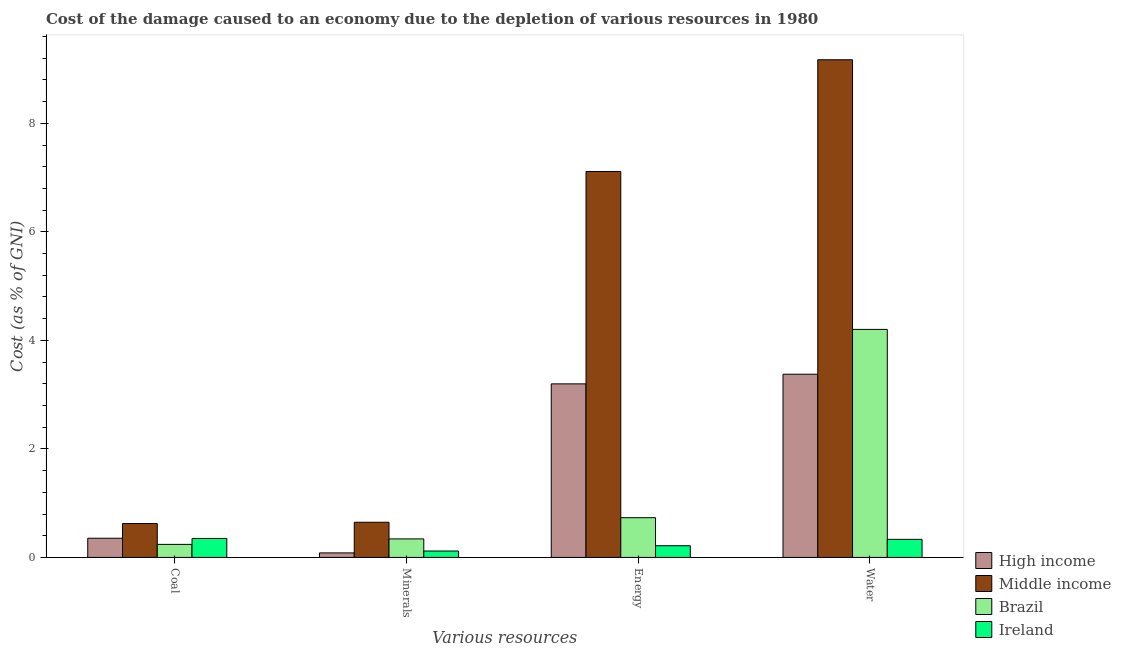How many different coloured bars are there?
Make the answer very short. 4. Are the number of bars per tick equal to the number of legend labels?
Keep it short and to the point. Yes. How many bars are there on the 4th tick from the left?
Your response must be concise. 4. How many bars are there on the 1st tick from the right?
Offer a very short reply. 4. What is the label of the 4th group of bars from the left?
Ensure brevity in your answer.  Water. What is the cost of damage due to depletion of coal in Middle income?
Your answer should be very brief. 0.62. Across all countries, what is the maximum cost of damage due to depletion of minerals?
Offer a very short reply. 0.65. Across all countries, what is the minimum cost of damage due to depletion of energy?
Give a very brief answer. 0.22. In which country was the cost of damage due to depletion of coal maximum?
Your response must be concise. Middle income. What is the total cost of damage due to depletion of water in the graph?
Keep it short and to the point. 17.08. What is the difference between the cost of damage due to depletion of water in Ireland and that in High income?
Keep it short and to the point. -3.04. What is the difference between the cost of damage due to depletion of minerals in Ireland and the cost of damage due to depletion of coal in High income?
Your answer should be very brief. -0.24. What is the average cost of damage due to depletion of minerals per country?
Offer a very short reply. 0.3. What is the difference between the cost of damage due to depletion of coal and cost of damage due to depletion of energy in Middle income?
Provide a succinct answer. -6.49. In how many countries, is the cost of damage due to depletion of water greater than 8.4 %?
Offer a terse response. 1. What is the ratio of the cost of damage due to depletion of coal in Brazil to that in High income?
Offer a very short reply. 0.68. What is the difference between the highest and the second highest cost of damage due to depletion of energy?
Offer a very short reply. 3.91. What is the difference between the highest and the lowest cost of damage due to depletion of minerals?
Give a very brief answer. 0.56. What does the 1st bar from the left in Minerals represents?
Offer a very short reply. High income. Is it the case that in every country, the sum of the cost of damage due to depletion of coal and cost of damage due to depletion of minerals is greater than the cost of damage due to depletion of energy?
Provide a short and direct response. No. How many countries are there in the graph?
Provide a short and direct response. 4. What is the difference between two consecutive major ticks on the Y-axis?
Provide a succinct answer. 2. Does the graph contain grids?
Ensure brevity in your answer.  No. How many legend labels are there?
Your response must be concise. 4. What is the title of the graph?
Offer a very short reply. Cost of the damage caused to an economy due to the depletion of various resources in 1980 . Does "Heavily indebted poor countries" appear as one of the legend labels in the graph?
Offer a very short reply. No. What is the label or title of the X-axis?
Offer a terse response. Various resources. What is the label or title of the Y-axis?
Your answer should be compact. Cost (as % of GNI). What is the Cost (as % of GNI) of High income in Coal?
Your response must be concise. 0.35. What is the Cost (as % of GNI) in Middle income in Coal?
Offer a very short reply. 0.62. What is the Cost (as % of GNI) in Brazil in Coal?
Your answer should be very brief. 0.24. What is the Cost (as % of GNI) of Ireland in Coal?
Provide a succinct answer. 0.35. What is the Cost (as % of GNI) of High income in Minerals?
Give a very brief answer. 0.08. What is the Cost (as % of GNI) of Middle income in Minerals?
Offer a terse response. 0.65. What is the Cost (as % of GNI) in Brazil in Minerals?
Make the answer very short. 0.34. What is the Cost (as % of GNI) in Ireland in Minerals?
Your response must be concise. 0.12. What is the Cost (as % of GNI) in High income in Energy?
Your response must be concise. 3.2. What is the Cost (as % of GNI) of Middle income in Energy?
Provide a short and direct response. 7.11. What is the Cost (as % of GNI) in Brazil in Energy?
Make the answer very short. 0.73. What is the Cost (as % of GNI) of Ireland in Energy?
Provide a short and direct response. 0.22. What is the Cost (as % of GNI) of High income in Water?
Provide a succinct answer. 3.38. What is the Cost (as % of GNI) of Middle income in Water?
Make the answer very short. 9.17. What is the Cost (as % of GNI) of Brazil in Water?
Provide a succinct answer. 4.2. What is the Cost (as % of GNI) of Ireland in Water?
Offer a terse response. 0.33. Across all Various resources, what is the maximum Cost (as % of GNI) of High income?
Offer a very short reply. 3.38. Across all Various resources, what is the maximum Cost (as % of GNI) of Middle income?
Offer a very short reply. 9.17. Across all Various resources, what is the maximum Cost (as % of GNI) of Brazil?
Keep it short and to the point. 4.2. Across all Various resources, what is the maximum Cost (as % of GNI) of Ireland?
Provide a short and direct response. 0.35. Across all Various resources, what is the minimum Cost (as % of GNI) of High income?
Make the answer very short. 0.08. Across all Various resources, what is the minimum Cost (as % of GNI) in Middle income?
Ensure brevity in your answer.  0.62. Across all Various resources, what is the minimum Cost (as % of GNI) in Brazil?
Your answer should be compact. 0.24. Across all Various resources, what is the minimum Cost (as % of GNI) of Ireland?
Offer a terse response. 0.12. What is the total Cost (as % of GNI) of High income in the graph?
Your answer should be compact. 7.01. What is the total Cost (as % of GNI) in Middle income in the graph?
Offer a very short reply. 17.56. What is the total Cost (as % of GNI) in Brazil in the graph?
Offer a terse response. 5.52. What is the total Cost (as % of GNI) of Ireland in the graph?
Give a very brief answer. 1.02. What is the difference between the Cost (as % of GNI) of High income in Coal and that in Minerals?
Offer a terse response. 0.27. What is the difference between the Cost (as % of GNI) in Middle income in Coal and that in Minerals?
Keep it short and to the point. -0.02. What is the difference between the Cost (as % of GNI) of Brazil in Coal and that in Minerals?
Your answer should be very brief. -0.1. What is the difference between the Cost (as % of GNI) of Ireland in Coal and that in Minerals?
Keep it short and to the point. 0.23. What is the difference between the Cost (as % of GNI) of High income in Coal and that in Energy?
Ensure brevity in your answer.  -2.85. What is the difference between the Cost (as % of GNI) of Middle income in Coal and that in Energy?
Ensure brevity in your answer.  -6.49. What is the difference between the Cost (as % of GNI) in Brazil in Coal and that in Energy?
Your answer should be compact. -0.49. What is the difference between the Cost (as % of GNI) in Ireland in Coal and that in Energy?
Your answer should be very brief. 0.13. What is the difference between the Cost (as % of GNI) of High income in Coal and that in Water?
Provide a short and direct response. -3.02. What is the difference between the Cost (as % of GNI) in Middle income in Coal and that in Water?
Your answer should be very brief. -8.55. What is the difference between the Cost (as % of GNI) of Brazil in Coal and that in Water?
Offer a terse response. -3.96. What is the difference between the Cost (as % of GNI) of Ireland in Coal and that in Water?
Provide a short and direct response. 0.02. What is the difference between the Cost (as % of GNI) in High income in Minerals and that in Energy?
Give a very brief answer. -3.12. What is the difference between the Cost (as % of GNI) in Middle income in Minerals and that in Energy?
Provide a short and direct response. -6.46. What is the difference between the Cost (as % of GNI) of Brazil in Minerals and that in Energy?
Provide a succinct answer. -0.39. What is the difference between the Cost (as % of GNI) of Ireland in Minerals and that in Energy?
Give a very brief answer. -0.1. What is the difference between the Cost (as % of GNI) in High income in Minerals and that in Water?
Provide a succinct answer. -3.29. What is the difference between the Cost (as % of GNI) of Middle income in Minerals and that in Water?
Make the answer very short. -8.52. What is the difference between the Cost (as % of GNI) of Brazil in Minerals and that in Water?
Your answer should be very brief. -3.86. What is the difference between the Cost (as % of GNI) in Ireland in Minerals and that in Water?
Keep it short and to the point. -0.22. What is the difference between the Cost (as % of GNI) in High income in Energy and that in Water?
Provide a succinct answer. -0.18. What is the difference between the Cost (as % of GNI) in Middle income in Energy and that in Water?
Offer a very short reply. -2.06. What is the difference between the Cost (as % of GNI) in Brazil in Energy and that in Water?
Offer a terse response. -3.47. What is the difference between the Cost (as % of GNI) in Ireland in Energy and that in Water?
Offer a terse response. -0.12. What is the difference between the Cost (as % of GNI) of High income in Coal and the Cost (as % of GNI) of Middle income in Minerals?
Offer a terse response. -0.29. What is the difference between the Cost (as % of GNI) of High income in Coal and the Cost (as % of GNI) of Brazil in Minerals?
Make the answer very short. 0.01. What is the difference between the Cost (as % of GNI) of High income in Coal and the Cost (as % of GNI) of Ireland in Minerals?
Provide a short and direct response. 0.24. What is the difference between the Cost (as % of GNI) in Middle income in Coal and the Cost (as % of GNI) in Brazil in Minerals?
Your answer should be compact. 0.28. What is the difference between the Cost (as % of GNI) in Middle income in Coal and the Cost (as % of GNI) in Ireland in Minerals?
Offer a very short reply. 0.51. What is the difference between the Cost (as % of GNI) in Brazil in Coal and the Cost (as % of GNI) in Ireland in Minerals?
Your response must be concise. 0.12. What is the difference between the Cost (as % of GNI) in High income in Coal and the Cost (as % of GNI) in Middle income in Energy?
Your answer should be very brief. -6.76. What is the difference between the Cost (as % of GNI) of High income in Coal and the Cost (as % of GNI) of Brazil in Energy?
Provide a succinct answer. -0.38. What is the difference between the Cost (as % of GNI) of High income in Coal and the Cost (as % of GNI) of Ireland in Energy?
Your answer should be very brief. 0.14. What is the difference between the Cost (as % of GNI) of Middle income in Coal and the Cost (as % of GNI) of Brazil in Energy?
Offer a terse response. -0.11. What is the difference between the Cost (as % of GNI) of Middle income in Coal and the Cost (as % of GNI) of Ireland in Energy?
Your answer should be very brief. 0.41. What is the difference between the Cost (as % of GNI) of Brazil in Coal and the Cost (as % of GNI) of Ireland in Energy?
Offer a very short reply. 0.03. What is the difference between the Cost (as % of GNI) in High income in Coal and the Cost (as % of GNI) in Middle income in Water?
Ensure brevity in your answer.  -8.82. What is the difference between the Cost (as % of GNI) in High income in Coal and the Cost (as % of GNI) in Brazil in Water?
Offer a terse response. -3.85. What is the difference between the Cost (as % of GNI) of High income in Coal and the Cost (as % of GNI) of Ireland in Water?
Offer a very short reply. 0.02. What is the difference between the Cost (as % of GNI) of Middle income in Coal and the Cost (as % of GNI) of Brazil in Water?
Ensure brevity in your answer.  -3.58. What is the difference between the Cost (as % of GNI) in Middle income in Coal and the Cost (as % of GNI) in Ireland in Water?
Provide a short and direct response. 0.29. What is the difference between the Cost (as % of GNI) in Brazil in Coal and the Cost (as % of GNI) in Ireland in Water?
Provide a short and direct response. -0.09. What is the difference between the Cost (as % of GNI) in High income in Minerals and the Cost (as % of GNI) in Middle income in Energy?
Provide a succinct answer. -7.03. What is the difference between the Cost (as % of GNI) of High income in Minerals and the Cost (as % of GNI) of Brazil in Energy?
Give a very brief answer. -0.65. What is the difference between the Cost (as % of GNI) of High income in Minerals and the Cost (as % of GNI) of Ireland in Energy?
Provide a short and direct response. -0.13. What is the difference between the Cost (as % of GNI) of Middle income in Minerals and the Cost (as % of GNI) of Brazil in Energy?
Give a very brief answer. -0.08. What is the difference between the Cost (as % of GNI) in Middle income in Minerals and the Cost (as % of GNI) in Ireland in Energy?
Offer a very short reply. 0.43. What is the difference between the Cost (as % of GNI) in Brazil in Minerals and the Cost (as % of GNI) in Ireland in Energy?
Give a very brief answer. 0.13. What is the difference between the Cost (as % of GNI) in High income in Minerals and the Cost (as % of GNI) in Middle income in Water?
Ensure brevity in your answer.  -9.09. What is the difference between the Cost (as % of GNI) of High income in Minerals and the Cost (as % of GNI) of Brazil in Water?
Offer a terse response. -4.12. What is the difference between the Cost (as % of GNI) of High income in Minerals and the Cost (as % of GNI) of Ireland in Water?
Your response must be concise. -0.25. What is the difference between the Cost (as % of GNI) of Middle income in Minerals and the Cost (as % of GNI) of Brazil in Water?
Keep it short and to the point. -3.55. What is the difference between the Cost (as % of GNI) of Middle income in Minerals and the Cost (as % of GNI) of Ireland in Water?
Your response must be concise. 0.32. What is the difference between the Cost (as % of GNI) in Brazil in Minerals and the Cost (as % of GNI) in Ireland in Water?
Offer a terse response. 0.01. What is the difference between the Cost (as % of GNI) in High income in Energy and the Cost (as % of GNI) in Middle income in Water?
Your answer should be very brief. -5.97. What is the difference between the Cost (as % of GNI) of High income in Energy and the Cost (as % of GNI) of Brazil in Water?
Ensure brevity in your answer.  -1. What is the difference between the Cost (as % of GNI) in High income in Energy and the Cost (as % of GNI) in Ireland in Water?
Provide a succinct answer. 2.87. What is the difference between the Cost (as % of GNI) in Middle income in Energy and the Cost (as % of GNI) in Brazil in Water?
Make the answer very short. 2.91. What is the difference between the Cost (as % of GNI) in Middle income in Energy and the Cost (as % of GNI) in Ireland in Water?
Provide a succinct answer. 6.78. What is the difference between the Cost (as % of GNI) in Brazil in Energy and the Cost (as % of GNI) in Ireland in Water?
Provide a succinct answer. 0.4. What is the average Cost (as % of GNI) of High income per Various resources?
Give a very brief answer. 1.75. What is the average Cost (as % of GNI) in Middle income per Various resources?
Your answer should be compact. 4.39. What is the average Cost (as % of GNI) of Brazil per Various resources?
Make the answer very short. 1.38. What is the average Cost (as % of GNI) in Ireland per Various resources?
Your response must be concise. 0.25. What is the difference between the Cost (as % of GNI) in High income and Cost (as % of GNI) in Middle income in Coal?
Give a very brief answer. -0.27. What is the difference between the Cost (as % of GNI) in High income and Cost (as % of GNI) in Brazil in Coal?
Your answer should be compact. 0.11. What is the difference between the Cost (as % of GNI) of High income and Cost (as % of GNI) of Ireland in Coal?
Offer a terse response. 0. What is the difference between the Cost (as % of GNI) in Middle income and Cost (as % of GNI) in Brazil in Coal?
Offer a very short reply. 0.38. What is the difference between the Cost (as % of GNI) in Middle income and Cost (as % of GNI) in Ireland in Coal?
Your answer should be very brief. 0.27. What is the difference between the Cost (as % of GNI) of Brazil and Cost (as % of GNI) of Ireland in Coal?
Ensure brevity in your answer.  -0.11. What is the difference between the Cost (as % of GNI) in High income and Cost (as % of GNI) in Middle income in Minerals?
Your answer should be very brief. -0.56. What is the difference between the Cost (as % of GNI) of High income and Cost (as % of GNI) of Brazil in Minerals?
Your answer should be very brief. -0.26. What is the difference between the Cost (as % of GNI) in High income and Cost (as % of GNI) in Ireland in Minerals?
Give a very brief answer. -0.03. What is the difference between the Cost (as % of GNI) in Middle income and Cost (as % of GNI) in Brazil in Minerals?
Offer a terse response. 0.31. What is the difference between the Cost (as % of GNI) of Middle income and Cost (as % of GNI) of Ireland in Minerals?
Your answer should be very brief. 0.53. What is the difference between the Cost (as % of GNI) in Brazil and Cost (as % of GNI) in Ireland in Minerals?
Provide a short and direct response. 0.22. What is the difference between the Cost (as % of GNI) of High income and Cost (as % of GNI) of Middle income in Energy?
Keep it short and to the point. -3.91. What is the difference between the Cost (as % of GNI) in High income and Cost (as % of GNI) in Brazil in Energy?
Provide a succinct answer. 2.47. What is the difference between the Cost (as % of GNI) in High income and Cost (as % of GNI) in Ireland in Energy?
Provide a short and direct response. 2.98. What is the difference between the Cost (as % of GNI) of Middle income and Cost (as % of GNI) of Brazil in Energy?
Provide a succinct answer. 6.38. What is the difference between the Cost (as % of GNI) of Middle income and Cost (as % of GNI) of Ireland in Energy?
Your answer should be very brief. 6.9. What is the difference between the Cost (as % of GNI) in Brazil and Cost (as % of GNI) in Ireland in Energy?
Offer a terse response. 0.52. What is the difference between the Cost (as % of GNI) of High income and Cost (as % of GNI) of Middle income in Water?
Your answer should be very brief. -5.8. What is the difference between the Cost (as % of GNI) of High income and Cost (as % of GNI) of Brazil in Water?
Make the answer very short. -0.83. What is the difference between the Cost (as % of GNI) in High income and Cost (as % of GNI) in Ireland in Water?
Keep it short and to the point. 3.04. What is the difference between the Cost (as % of GNI) of Middle income and Cost (as % of GNI) of Brazil in Water?
Ensure brevity in your answer.  4.97. What is the difference between the Cost (as % of GNI) in Middle income and Cost (as % of GNI) in Ireland in Water?
Your answer should be compact. 8.84. What is the difference between the Cost (as % of GNI) in Brazil and Cost (as % of GNI) in Ireland in Water?
Provide a succinct answer. 3.87. What is the ratio of the Cost (as % of GNI) of High income in Coal to that in Minerals?
Provide a short and direct response. 4.24. What is the ratio of the Cost (as % of GNI) of Middle income in Coal to that in Minerals?
Offer a very short reply. 0.96. What is the ratio of the Cost (as % of GNI) of Brazil in Coal to that in Minerals?
Provide a short and direct response. 0.7. What is the ratio of the Cost (as % of GNI) of Ireland in Coal to that in Minerals?
Your answer should be compact. 2.97. What is the ratio of the Cost (as % of GNI) of High income in Coal to that in Energy?
Your answer should be compact. 0.11. What is the ratio of the Cost (as % of GNI) of Middle income in Coal to that in Energy?
Keep it short and to the point. 0.09. What is the ratio of the Cost (as % of GNI) in Brazil in Coal to that in Energy?
Make the answer very short. 0.33. What is the ratio of the Cost (as % of GNI) in Ireland in Coal to that in Energy?
Your response must be concise. 1.63. What is the ratio of the Cost (as % of GNI) of High income in Coal to that in Water?
Provide a succinct answer. 0.1. What is the ratio of the Cost (as % of GNI) in Middle income in Coal to that in Water?
Ensure brevity in your answer.  0.07. What is the ratio of the Cost (as % of GNI) in Brazil in Coal to that in Water?
Give a very brief answer. 0.06. What is the ratio of the Cost (as % of GNI) of Ireland in Coal to that in Water?
Keep it short and to the point. 1.05. What is the ratio of the Cost (as % of GNI) of High income in Minerals to that in Energy?
Your response must be concise. 0.03. What is the ratio of the Cost (as % of GNI) in Middle income in Minerals to that in Energy?
Offer a terse response. 0.09. What is the ratio of the Cost (as % of GNI) of Brazil in Minerals to that in Energy?
Ensure brevity in your answer.  0.47. What is the ratio of the Cost (as % of GNI) of Ireland in Minerals to that in Energy?
Give a very brief answer. 0.55. What is the ratio of the Cost (as % of GNI) in High income in Minerals to that in Water?
Your response must be concise. 0.02. What is the ratio of the Cost (as % of GNI) in Middle income in Minerals to that in Water?
Make the answer very short. 0.07. What is the ratio of the Cost (as % of GNI) of Brazil in Minerals to that in Water?
Your answer should be very brief. 0.08. What is the ratio of the Cost (as % of GNI) of Ireland in Minerals to that in Water?
Provide a short and direct response. 0.35. What is the ratio of the Cost (as % of GNI) of Middle income in Energy to that in Water?
Offer a terse response. 0.78. What is the ratio of the Cost (as % of GNI) in Brazil in Energy to that in Water?
Your response must be concise. 0.17. What is the ratio of the Cost (as % of GNI) in Ireland in Energy to that in Water?
Offer a terse response. 0.65. What is the difference between the highest and the second highest Cost (as % of GNI) of High income?
Offer a terse response. 0.18. What is the difference between the highest and the second highest Cost (as % of GNI) of Middle income?
Offer a very short reply. 2.06. What is the difference between the highest and the second highest Cost (as % of GNI) of Brazil?
Provide a short and direct response. 3.47. What is the difference between the highest and the second highest Cost (as % of GNI) in Ireland?
Your answer should be very brief. 0.02. What is the difference between the highest and the lowest Cost (as % of GNI) of High income?
Give a very brief answer. 3.29. What is the difference between the highest and the lowest Cost (as % of GNI) in Middle income?
Provide a short and direct response. 8.55. What is the difference between the highest and the lowest Cost (as % of GNI) of Brazil?
Offer a terse response. 3.96. What is the difference between the highest and the lowest Cost (as % of GNI) in Ireland?
Make the answer very short. 0.23. 